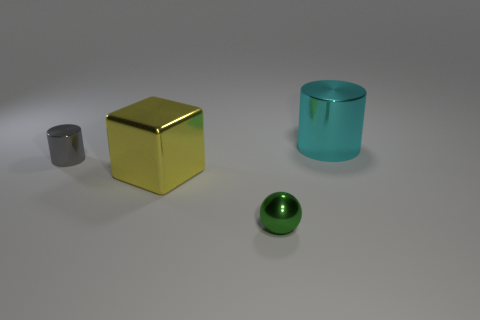Are there any other things that have the same material as the green sphere?
Your answer should be compact. Yes. Is the number of cyan shiny cubes greater than the number of metallic things?
Provide a short and direct response. No. What is the size of the gray cylinder that is made of the same material as the small sphere?
Your answer should be compact. Small. What is the gray cylinder made of?
Keep it short and to the point. Metal. What number of green objects have the same size as the metallic cube?
Your answer should be very brief. 0. Is there another big thing of the same shape as the gray thing?
Offer a very short reply. Yes. What is the color of the shiny block that is the same size as the cyan metal object?
Make the answer very short. Yellow. There is a metallic cylinder right of the big thing in front of the big cyan metal object; what color is it?
Provide a short and direct response. Cyan. The small thing that is in front of the big object on the left side of the big shiny object that is to the right of the green metallic ball is what shape?
Keep it short and to the point. Sphere. What number of cylinders are behind the metal cylinder left of the big cyan thing?
Make the answer very short. 1. 